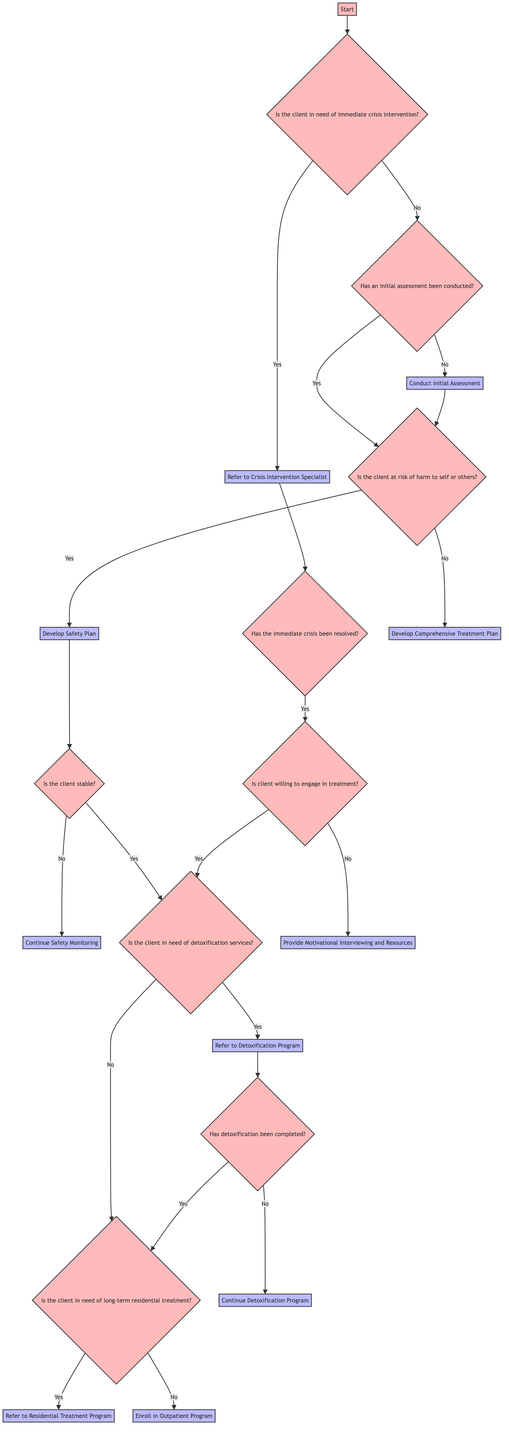What is the initial question asked when starting the workflow? The initial question posed in the workflow is found directly under the "Start" node, which asks if the client is in need of immediate crisis intervention.
Answer: Is the client in need of immediate crisis intervention? How many action nodes are present in the diagram? To find the action nodes, we look through the entire flowchart and count every node that provides an action rather than a question. There are eight action nodes in total, which include actions under different paths.
Answer: Eight What happens if the client is not willing to engage in treatment? According to the diagram, if the client is not willing to engage in treatment, the flow leads to the action of providing motivational interviewing and resources. This outcome is derived from the path that follows the "Is client willing to engage in treatment?" question.
Answer: Provide Motivational Interviewing and Resources If detoxification is needed and completed, what is the next step? When detoxification services are determined to be needed and the detoxification is confirmed to be completed, the workflow leads to the question about whether the client needs long-term residential treatment. This process is found after the "Has detoxification been completed?" node.
Answer: Is the client in need of long-term residential treatment? Describe the action taken if the client is at risk of harm to self or others? When the diagram indicates that the client is at risk of harm to self or others, the action taken is to develop a safety plan. This is the response under the "Is the client at risk of harm to self or others?" question.
Answer: Develop Safety Plan What leads to the enrollment in the outpatient program? The decision for enrolling in the outpatient program occurs if it is determined that the client does not require detoxification services or long-term residential treatment. This outcome emerges from the flowchart paths that analyze both detoxification needs and residential treatment needs leading to this action.
Answer: Enroll in Outpatient Program What does the diagram suggest if the immediate crisis has not been resolved? If the immediate crisis has not been resolved after referring to a crisis intervention specialist, the workflow does not specify an action, suggesting that further steps are needed, possibly re-evaluating the crisis status.
Answer: (No action specified) What indicates a need for safety monitoring? Safety monitoring is required if, after having developed a safety plan, the client is not deemed stable. This ties back to the decision node asking if the client is stable, so monitoring is an action if the answer is "No."
Answer: Continue Safety Monitoring 